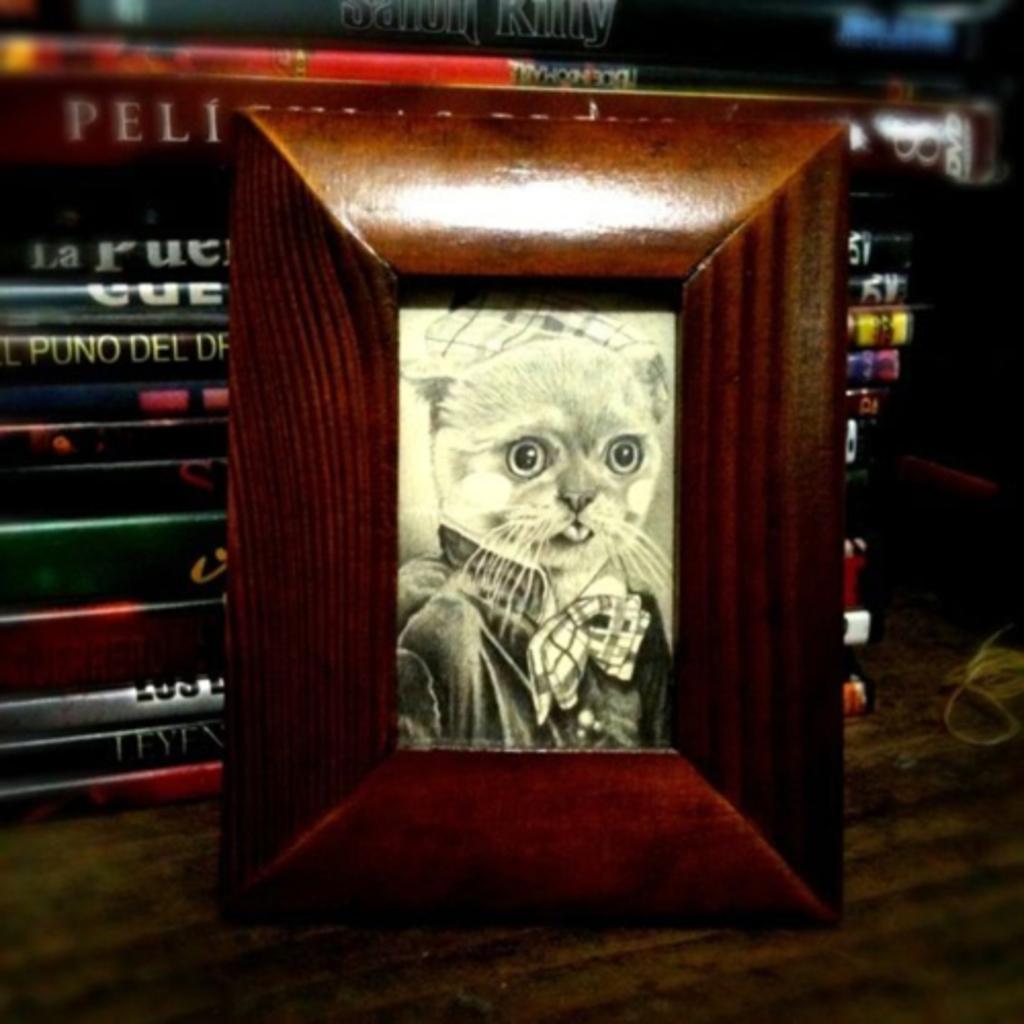Could you give a brief overview of what you see in this image? In this picture, there is a frame. In the frame, there is a cat. In the background, there are books. 